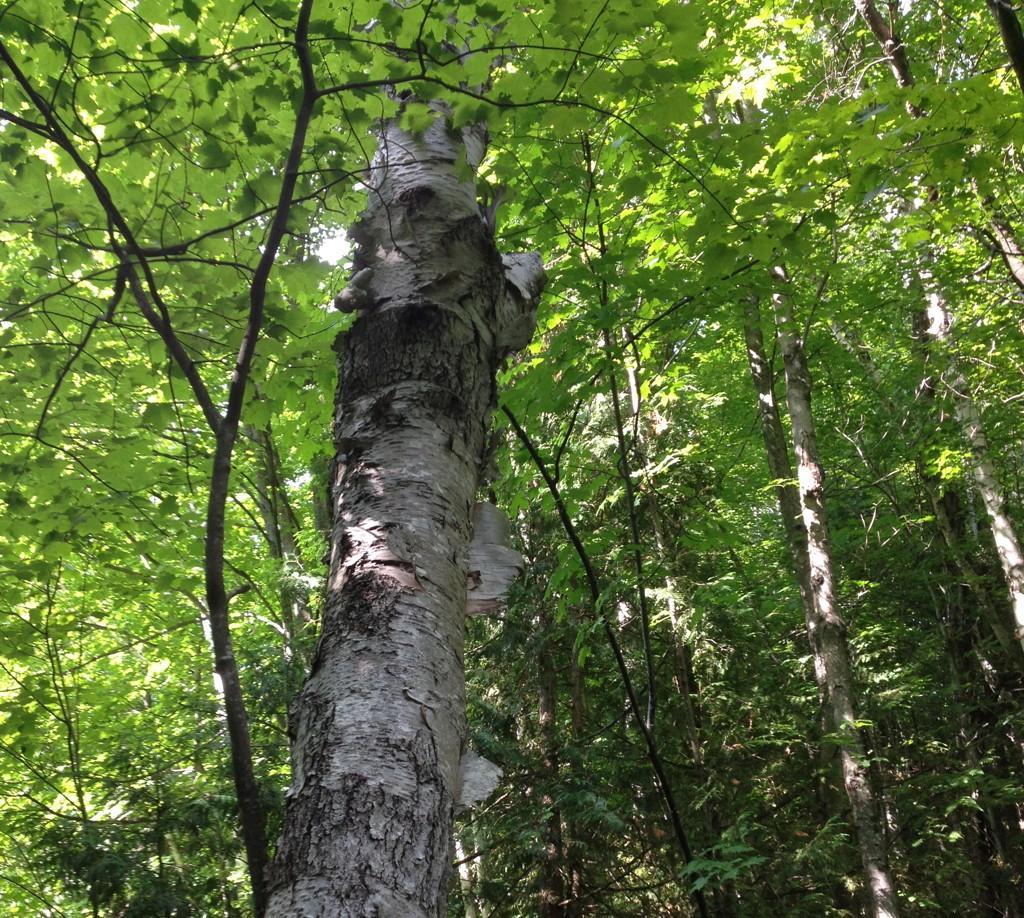Can you describe this image briefly? In this image we can see the trees. 